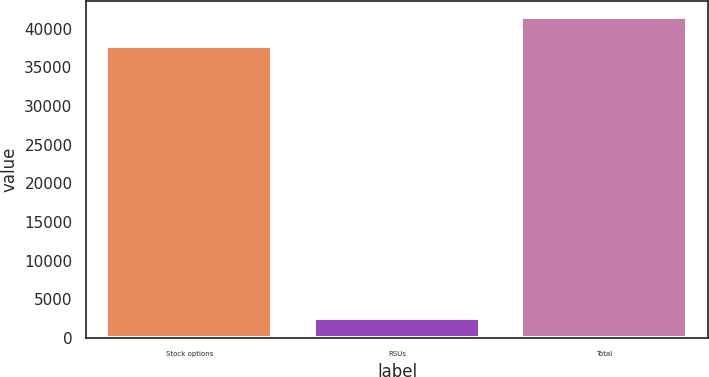<chart> <loc_0><loc_0><loc_500><loc_500><bar_chart><fcel>Stock options<fcel>RSUs<fcel>Total<nl><fcel>37696<fcel>2610<fcel>41465.6<nl></chart> 